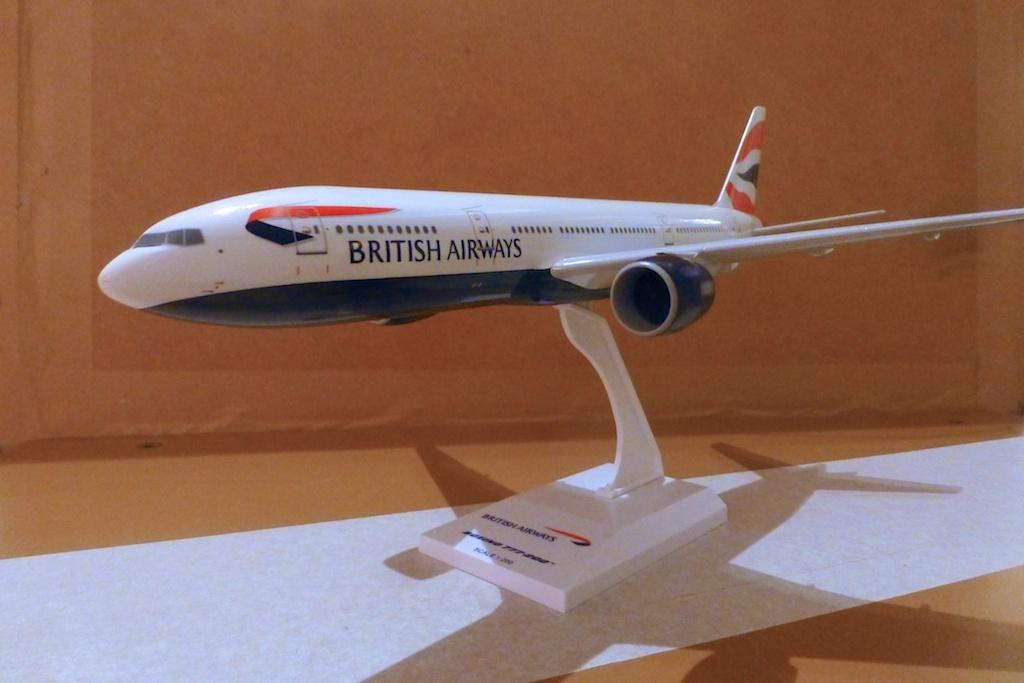What's the airline's name?
Offer a terse response. British airways. 